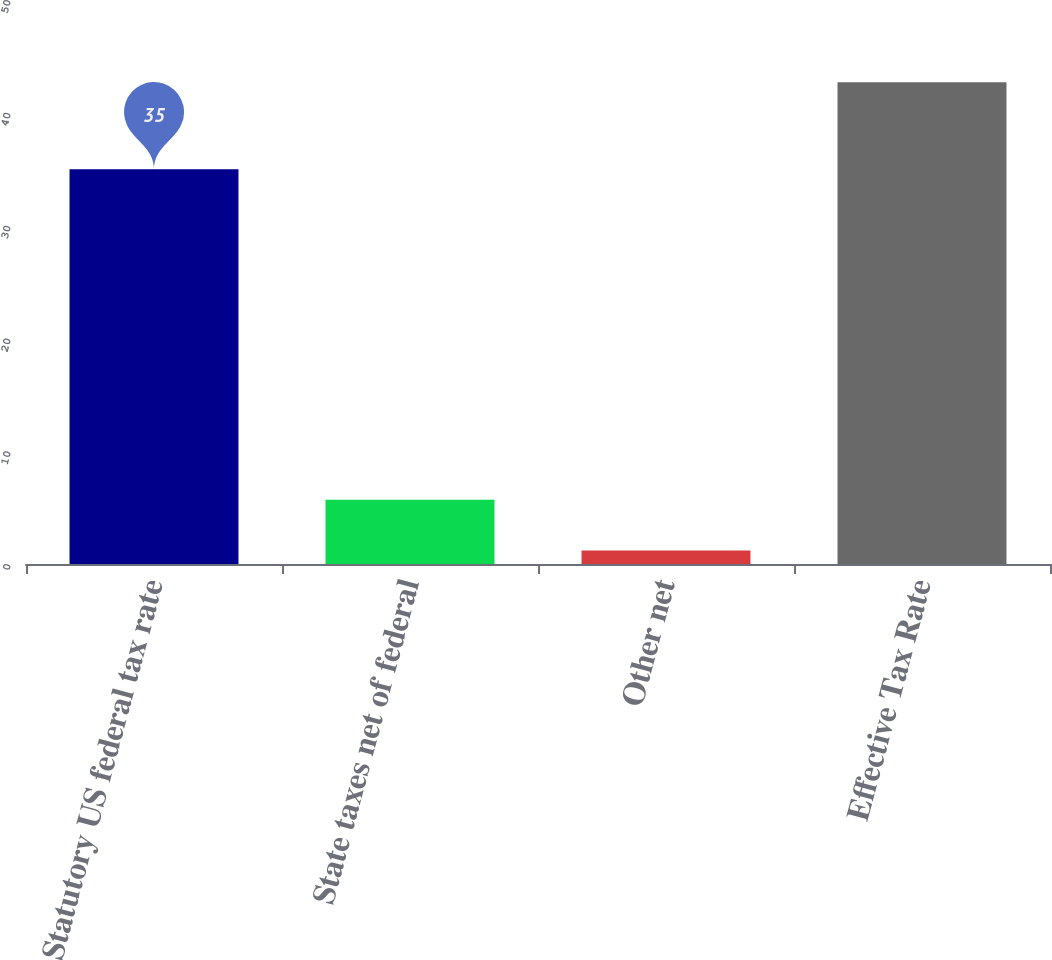Convert chart to OTSL. <chart><loc_0><loc_0><loc_500><loc_500><bar_chart><fcel>Statutory US federal tax rate<fcel>State taxes net of federal<fcel>Other net<fcel>Effective Tax Rate<nl><fcel>35<fcel>5.7<fcel>1.2<fcel>42.7<nl></chart> 